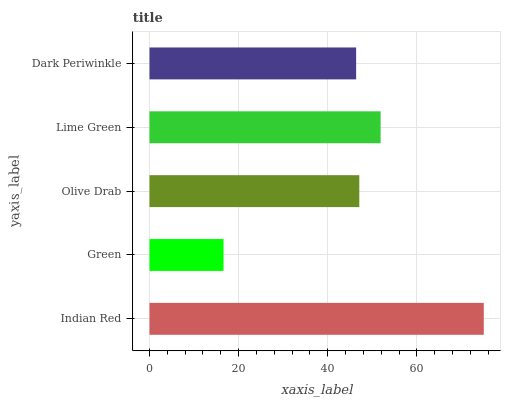Is Green the minimum?
Answer yes or no. Yes. Is Indian Red the maximum?
Answer yes or no. Yes. Is Olive Drab the minimum?
Answer yes or no. No. Is Olive Drab the maximum?
Answer yes or no. No. Is Olive Drab greater than Green?
Answer yes or no. Yes. Is Green less than Olive Drab?
Answer yes or no. Yes. Is Green greater than Olive Drab?
Answer yes or no. No. Is Olive Drab less than Green?
Answer yes or no. No. Is Olive Drab the high median?
Answer yes or no. Yes. Is Olive Drab the low median?
Answer yes or no. Yes. Is Green the high median?
Answer yes or no. No. Is Green the low median?
Answer yes or no. No. 